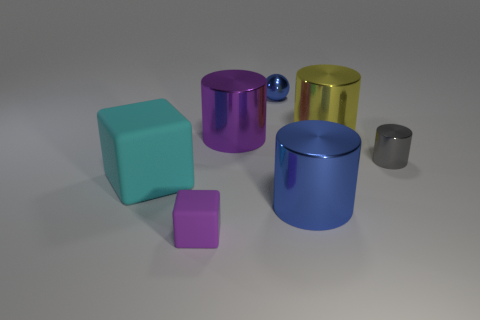What number of other things are there of the same shape as the small gray metal thing?
Your response must be concise. 3. What number of large gray balls have the same material as the yellow object?
Provide a short and direct response. 0. What is the shape of the large thing that is the same color as the metal ball?
Offer a terse response. Cylinder. Is the number of big things that are behind the blue cylinder the same as the number of large cyan blocks?
Offer a terse response. No. What size is the cube that is left of the tiny purple rubber block?
Your answer should be compact. Large. How many tiny objects are either blue balls or yellow metal objects?
Your response must be concise. 1. What is the color of the other small thing that is the same shape as the cyan matte thing?
Offer a very short reply. Purple. Is the gray cylinder the same size as the cyan matte block?
Your answer should be compact. No. How many objects are tiny blue cylinders or blue things left of the blue shiny cylinder?
Your response must be concise. 1. There is a tiny rubber object on the right side of the rubber block that is on the left side of the tiny purple cube; what is its color?
Your response must be concise. Purple. 